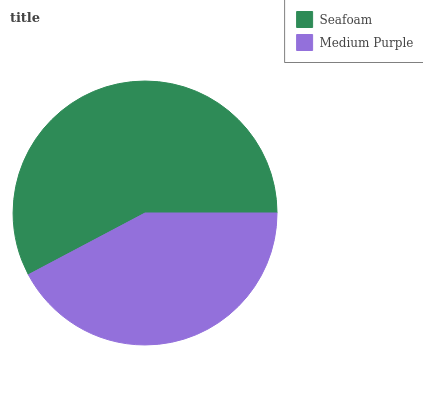Is Medium Purple the minimum?
Answer yes or no. Yes. Is Seafoam the maximum?
Answer yes or no. Yes. Is Medium Purple the maximum?
Answer yes or no. No. Is Seafoam greater than Medium Purple?
Answer yes or no. Yes. Is Medium Purple less than Seafoam?
Answer yes or no. Yes. Is Medium Purple greater than Seafoam?
Answer yes or no. No. Is Seafoam less than Medium Purple?
Answer yes or no. No. Is Seafoam the high median?
Answer yes or no. Yes. Is Medium Purple the low median?
Answer yes or no. Yes. Is Medium Purple the high median?
Answer yes or no. No. Is Seafoam the low median?
Answer yes or no. No. 